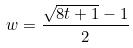<formula> <loc_0><loc_0><loc_500><loc_500>w = \frac { \sqrt { 8 t + 1 } - 1 } { 2 }</formula> 